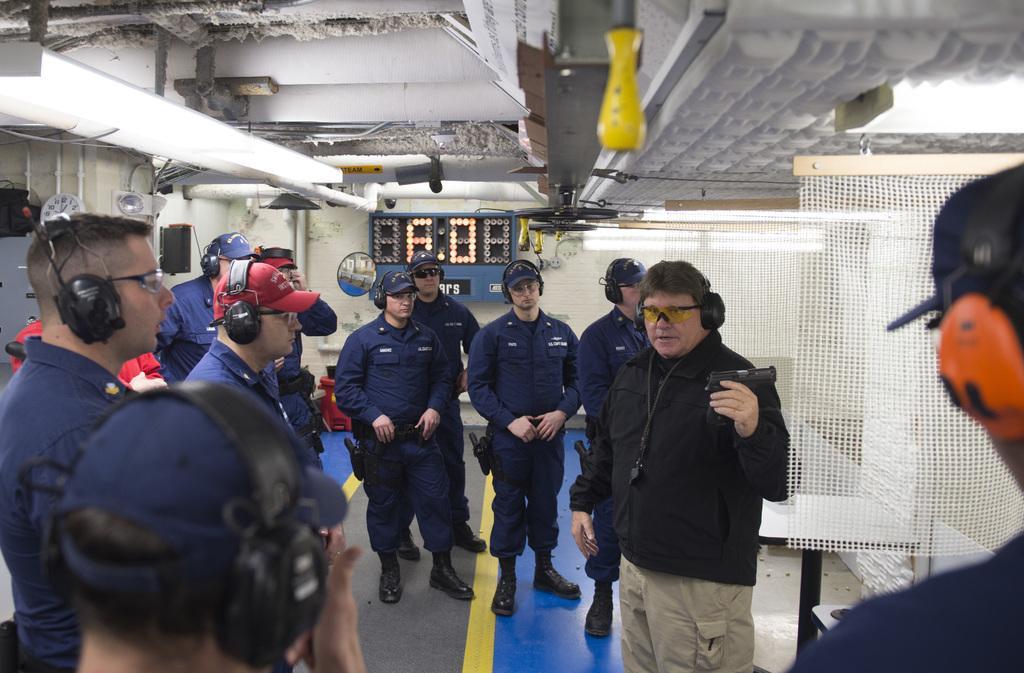How would you summarize this image in a sentence or two? In this image, there are some persons standing and wearing headphones. There is a clock in the middle of the image. There is a person at the bottom of the image holding a gun with his hand. There is a mesh on the right side of the image. 